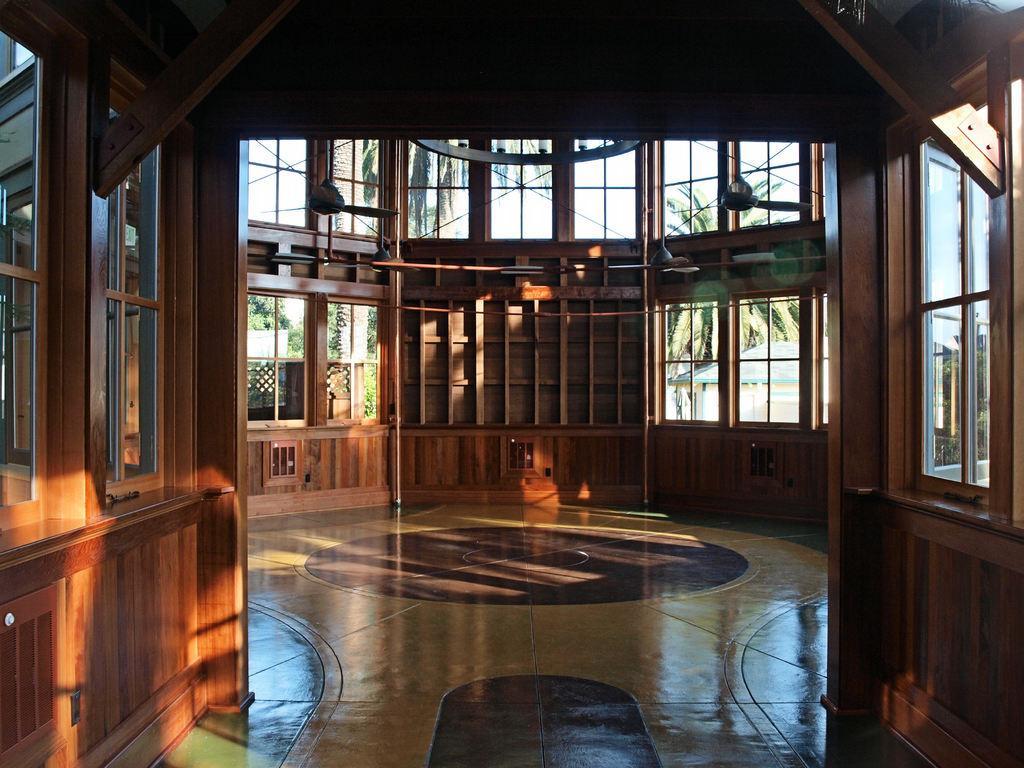How would you summarize this image in a sentence or two? In this image we can see the inside view of a wooden building. 